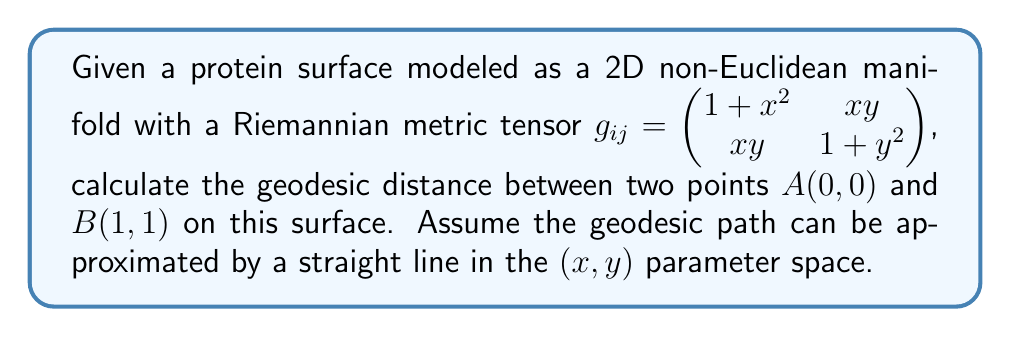Teach me how to tackle this problem. To calculate the geodesic distance between two points on a non-Euclidean manifold, we need to use the formula for arc length in Riemannian geometry:

$$s = \int_a^b \sqrt{g_{ij}\frac{dx^i}{dt}\frac{dx^j}{dt}}dt$$

Where $g_{ij}$ is the metric tensor, and $\frac{dx^i}{dt}$ and $\frac{dx^j}{dt}$ are the components of the velocity vector.

Step 1: Parameterize the path
Assuming a straight line in the parameter space, we can parameterize the path from $A(0,0)$ to $B(1,1)$ as:
$x(t) = t$, $y(t) = t$, where $0 \leq t \leq 1$

Step 2: Calculate the velocity components
$\frac{dx}{dt} = 1$, $\frac{dy}{dt} = 1$

Step 3: Substitute into the arc length formula
$$s = \int_0^1 \sqrt{g_{11}(\frac{dx}{dt})^2 + 2g_{12}\frac{dx}{dt}\frac{dy}{dt} + g_{22}(\frac{dy}{dt})^2}dt$$

$$s = \int_0^1 \sqrt{(1+t^2)(1)^2 + 2(t^2)(1)(1) + (1+t^2)(1)^2}dt$$

$$s = \int_0^1 \sqrt{1+t^2 + 2t^2 + 1+t^2}dt$$

$$s = \int_0^1 \sqrt{2 + 4t^2}dt$$

Step 4: Solve the integral
$$s = \frac{1}{4}\int_0^1 \sqrt{2 + 4t^2}d(2t^2)$$

Let $u = 2t^2$, then $du = 4tdt$

$$s = \frac{1}{4}\int_0^2 \sqrt{2 + u}du$$

$$s = \frac{1}{4}[\frac{2}{3}(2+u)^{3/2}]_0^2$$

$$s = \frac{1}{6}[(4)^{3/2} - (2)^{3/2}]$$

$$s = \frac{1}{6}(8\sqrt{2} - 2\sqrt{2})$$

$$s = \frac{\sqrt{2}}{3}(4 - 1)$$

$$s = \frac{\sqrt{2}}{3}(3)$$

$$s = \sqrt{2}$$
Answer: $\sqrt{2}$ 